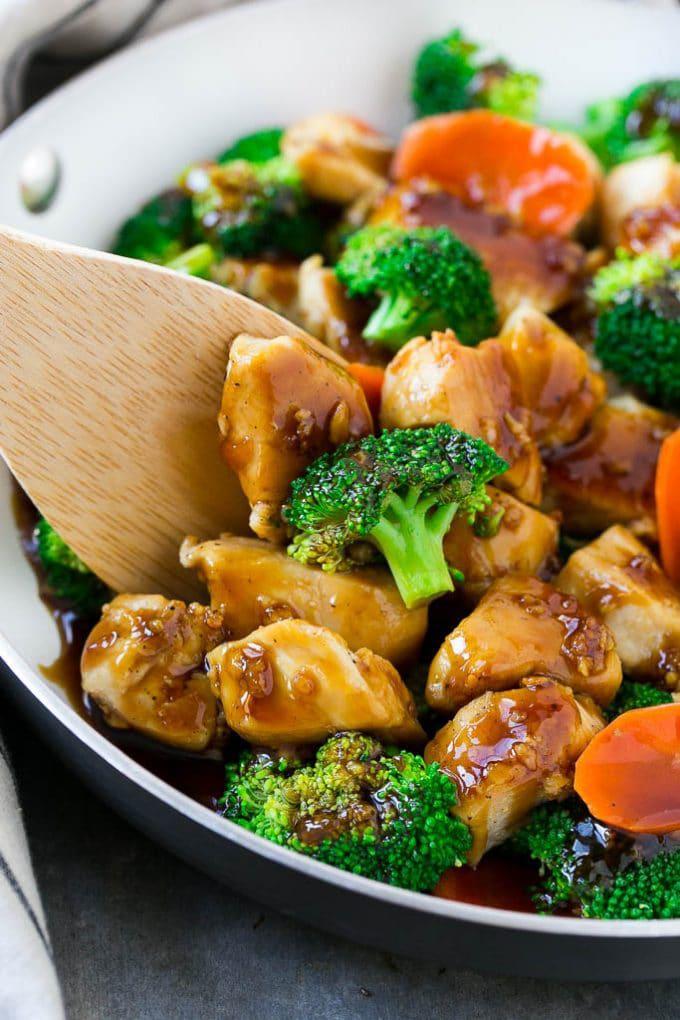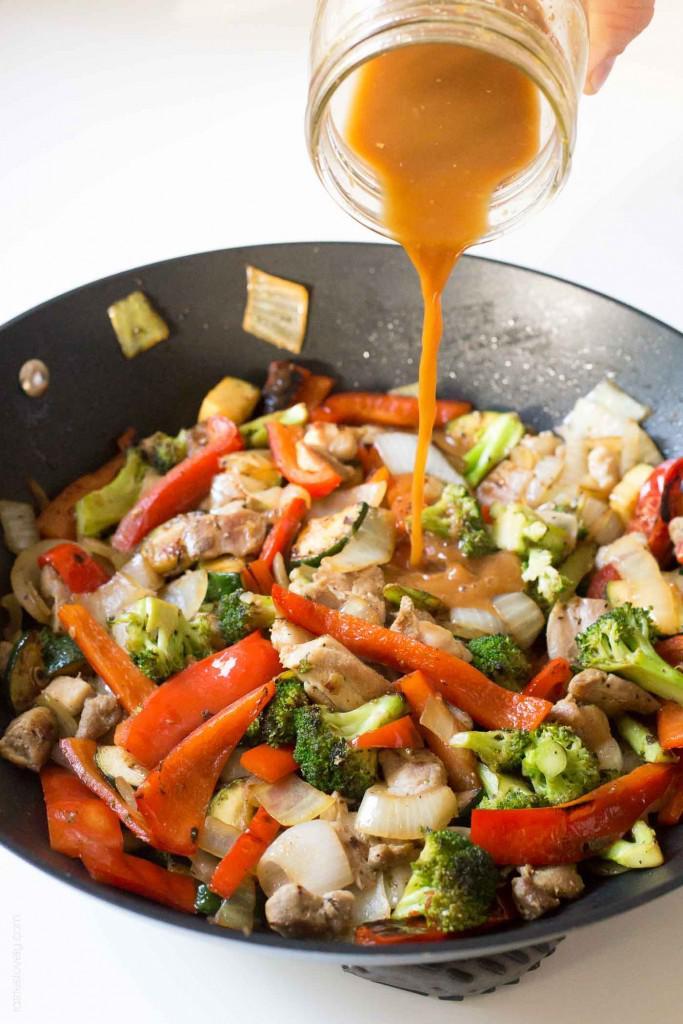The first image is the image on the left, the second image is the image on the right. Analyze the images presented: Is the assertion "The left and right image contains two white bowl of broccoli and chickens." valid? Answer yes or no. No. The first image is the image on the left, the second image is the image on the right. Analyze the images presented: Is the assertion "A fork is inside the bowl of one of the stir-frys in one image." valid? Answer yes or no. No. 